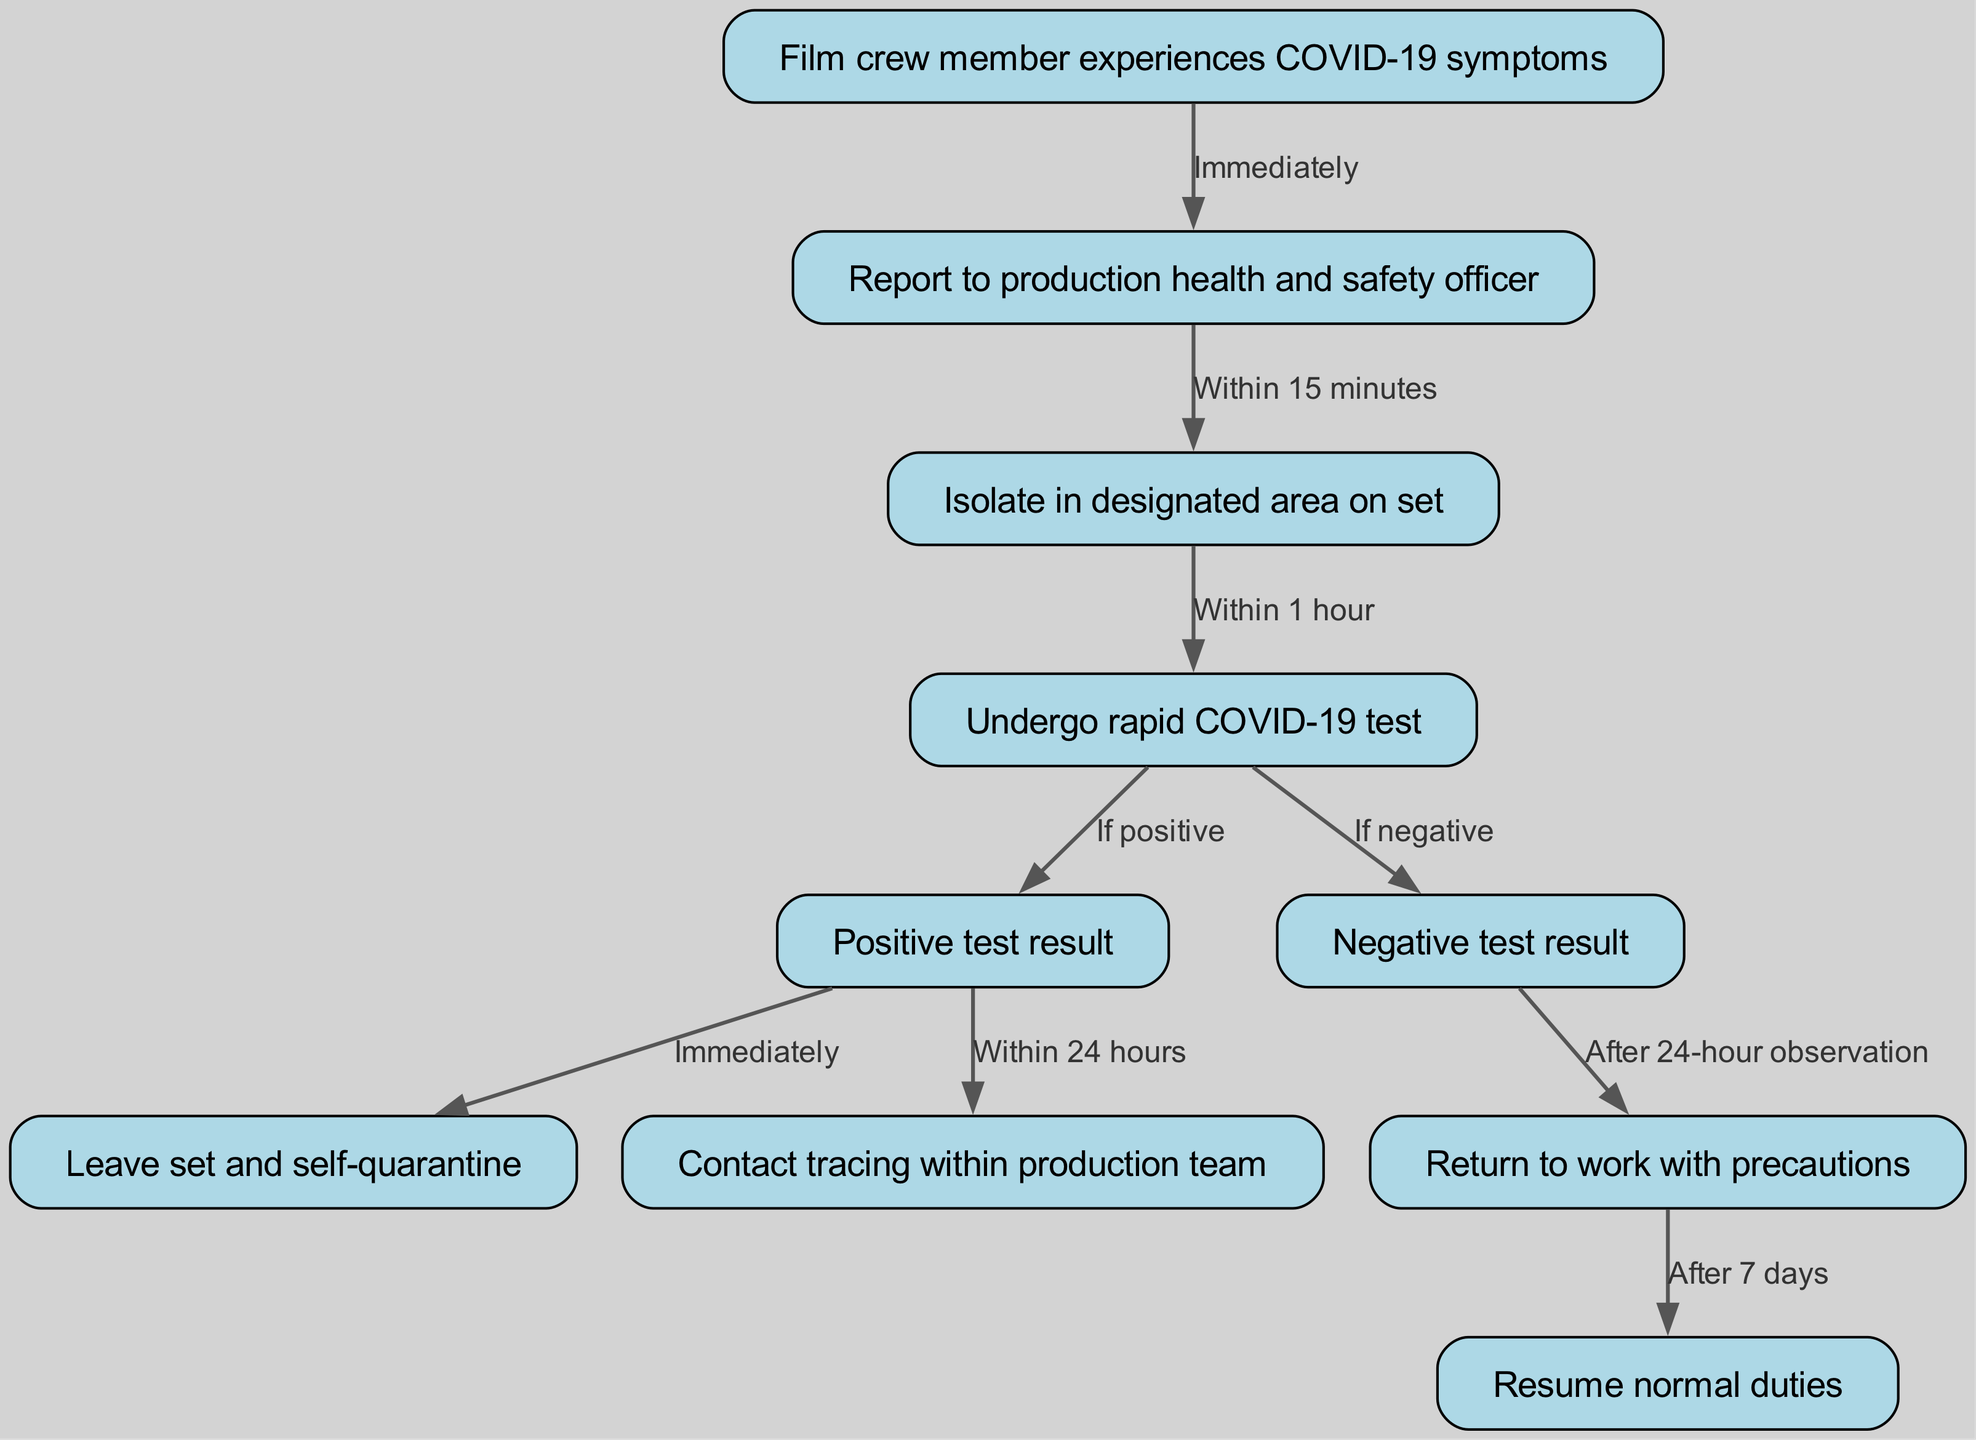What is the first step for a film crew member experiencing COVID-19 symptoms? The diagram indicates that the first step is that the film crew member experiences COVID-19 symptoms, which directly leads to reporting to the production health and safety officer.
Answer: Report to production health and safety officer How long does a crew member have to report to the health and safety officer? According to the arrows connecting the nodes, the crew member must report to the health and safety officer within 15 minutes after experiencing symptoms.
Answer: Within 15 minutes What happens if the rapid COVID-19 test is positive? The diagram shows that if the rapid COVID-19 test result is positive, the crew member must leave set and self-quarantine immediately.
Answer: Leave set and self-quarantine What action follows a negative test result after a 24-hour observation? The flow indicates that after observing the crew member for 24 hours post-negative test, they are allowed to return to work with precautions.
Answer: Return to work with precautions How many total nodes are present in the diagram? By counting the nodes listed in the diagram, there are a total of 10 distinct steps or nodes representing actions and decisions in the pathway.
Answer: 10 What is the maximum time frame for contact tracing to occur after a positive test result? The diagram specifies that contact tracing within the production team must occur within 24 hours after a positive test result.
Answer: Within 24 hours What precautionary step is indicated after returning to work? The pathway shows that after returning to work with precautions, the next step is for the crew member to resume normal duties, indicating they are well and cleared to work fully.
Answer: Resume normal duties What is the relation between the nodes "Isolate in designated area on set" and "Undergo rapid COVID-19 test"? The diagram illustrates that isolation occurs in a designated area on set, leading directly to the next action, which is to undergo a rapid COVID-19 test, indicating that isolation is a prerequisite for testing.
Answer: Isolate in designated area on set → Undergo rapid COVID-19 test If a crew member tests negative, how long must they be observed before returning to work? According to the pathway, after receiving a negative test result, the crew member must undergo a 24-hour observation before they can return to work with precautions.
Answer: After 24-hour observation 